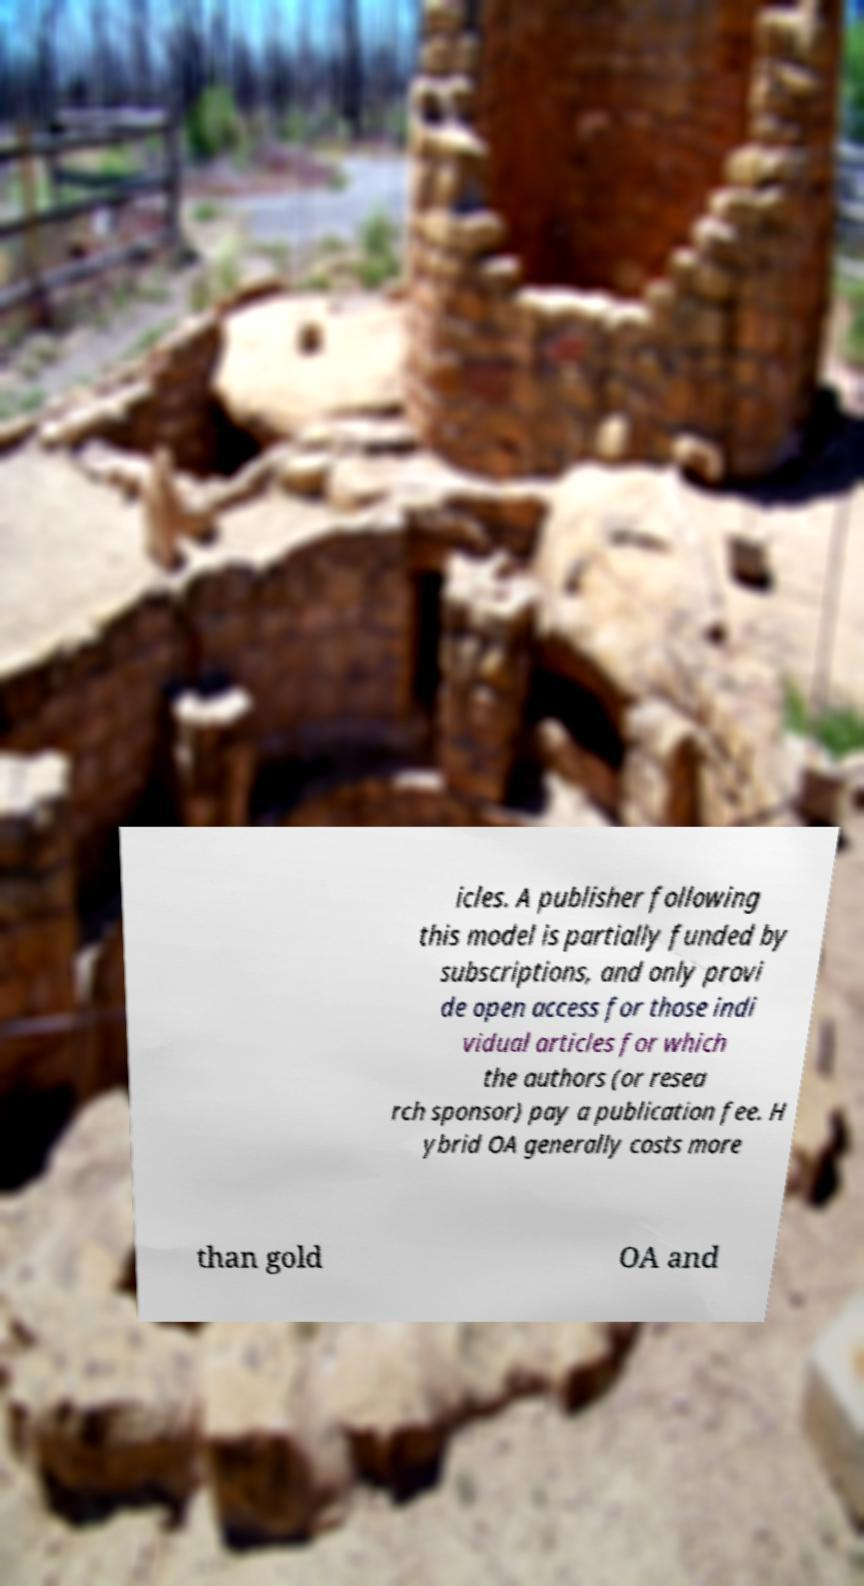There's text embedded in this image that I need extracted. Can you transcribe it verbatim? icles. A publisher following this model is partially funded by subscriptions, and only provi de open access for those indi vidual articles for which the authors (or resea rch sponsor) pay a publication fee. H ybrid OA generally costs more than gold OA and 